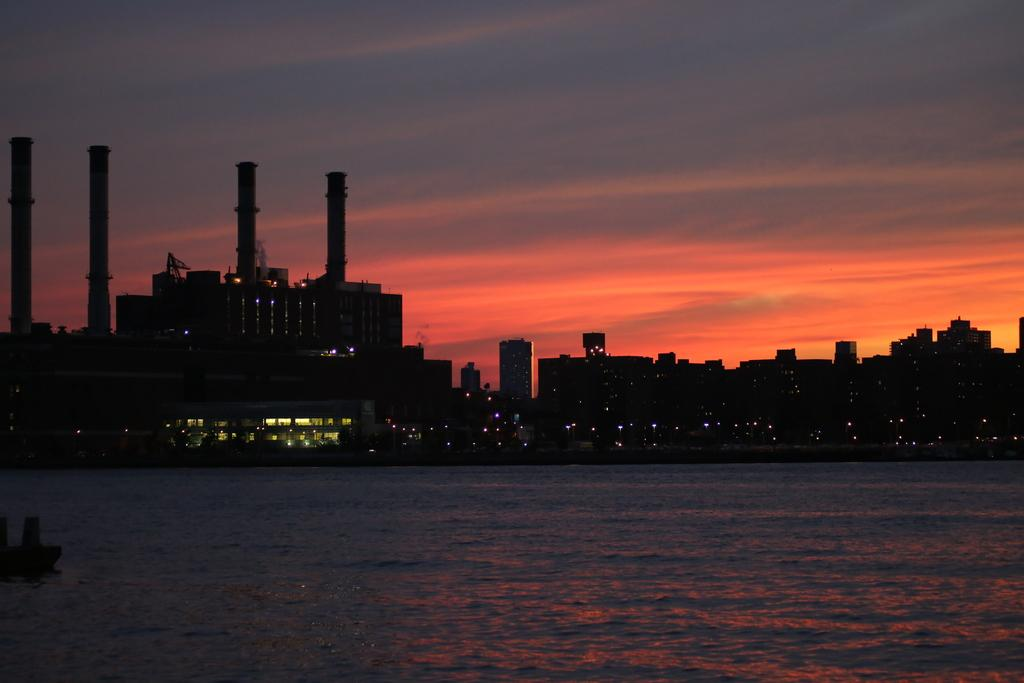What is present at the bottom of the image? There is water at the bottom of the image. What can be seen in the middle of the image? There are buildings with lights in the middle of the image. What is located on the left side of the image? There appears to be a ship on the left side of the image. What is visible at the top of the image? The sky is visible at the top of the image. How does the paste stick to the side of the ship in the image? There is no paste present in the image, and therefore no such interaction can be observed. What type of fight is taking place in the middle of the image? There is no fight depicted in the image; it features buildings with lights. 